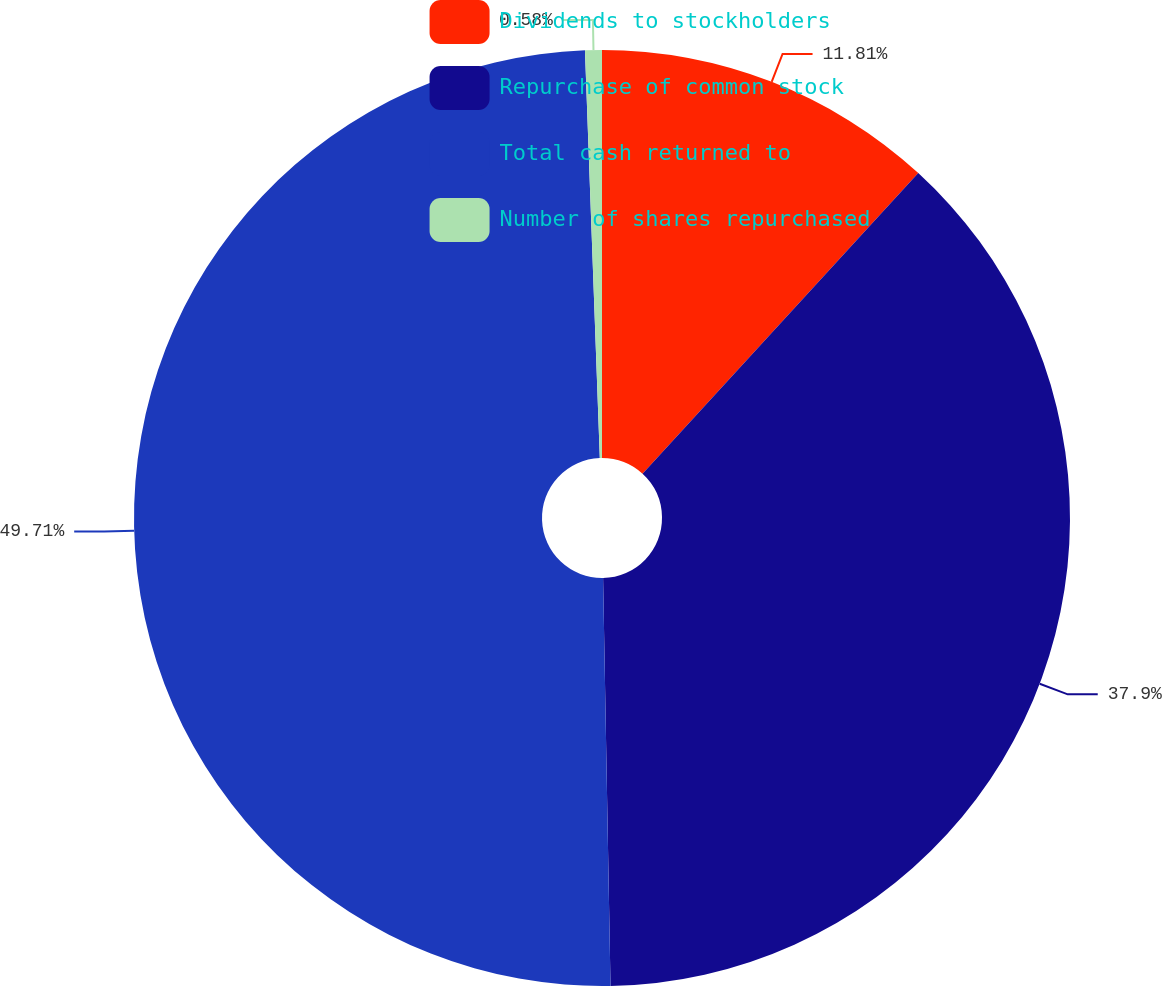Convert chart. <chart><loc_0><loc_0><loc_500><loc_500><pie_chart><fcel>Dividends to stockholders<fcel>Repurchase of common stock<fcel>Total cash returned to<fcel>Number of shares repurchased<nl><fcel>11.81%<fcel>37.9%<fcel>49.71%<fcel>0.58%<nl></chart> 